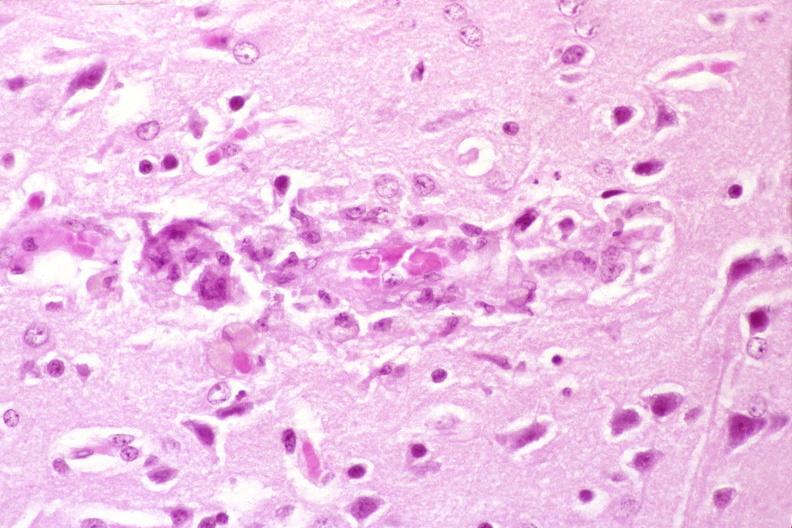s nervous present?
Answer the question using a single word or phrase. Yes 